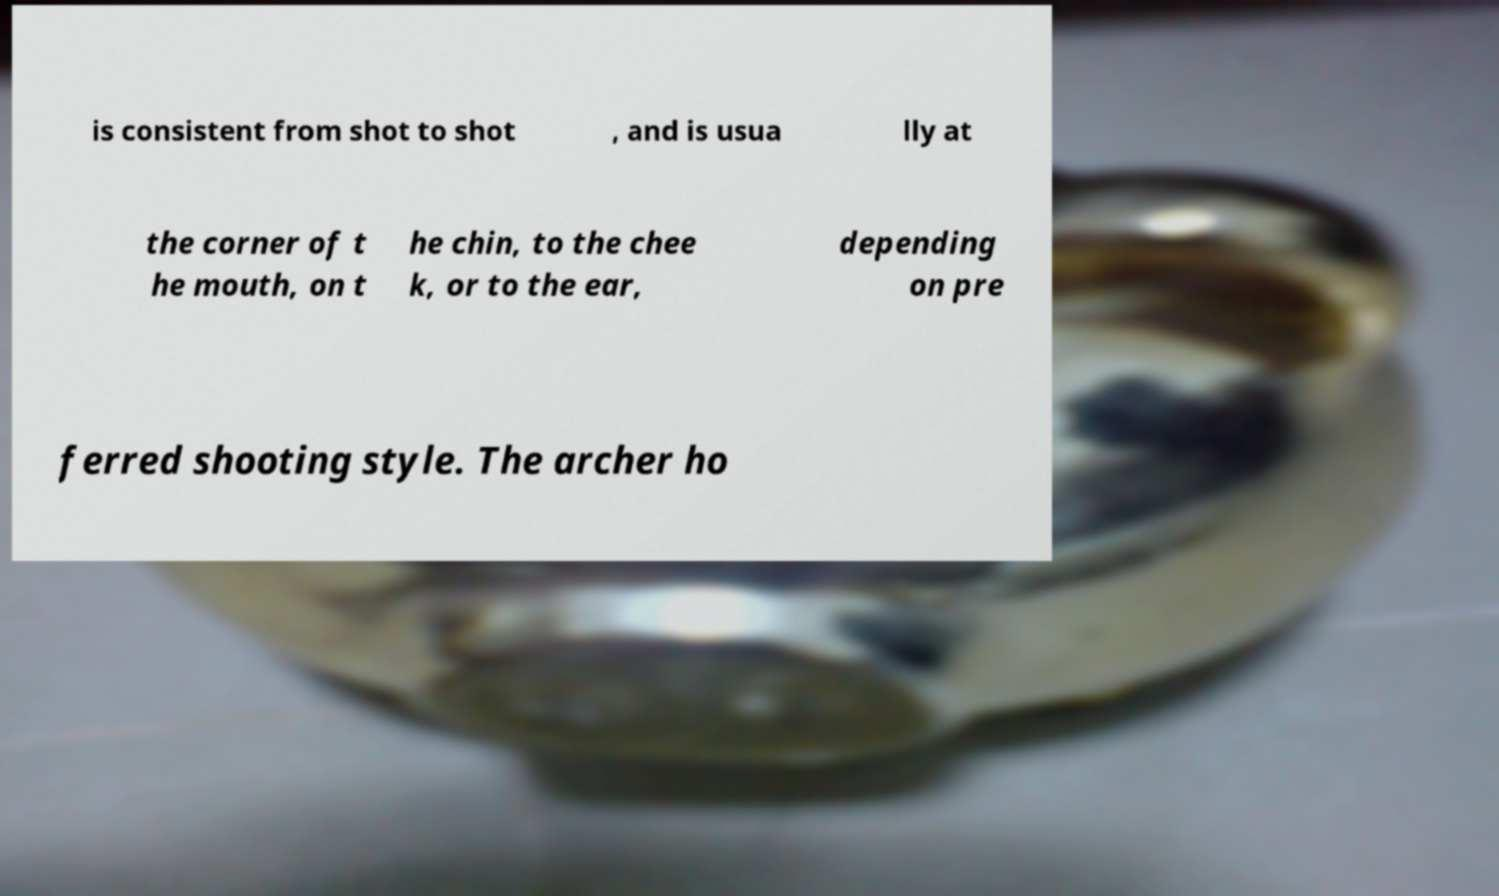Can you read and provide the text displayed in the image?This photo seems to have some interesting text. Can you extract and type it out for me? is consistent from shot to shot , and is usua lly at the corner of t he mouth, on t he chin, to the chee k, or to the ear, depending on pre ferred shooting style. The archer ho 